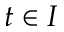<formula> <loc_0><loc_0><loc_500><loc_500>t \in I</formula> 